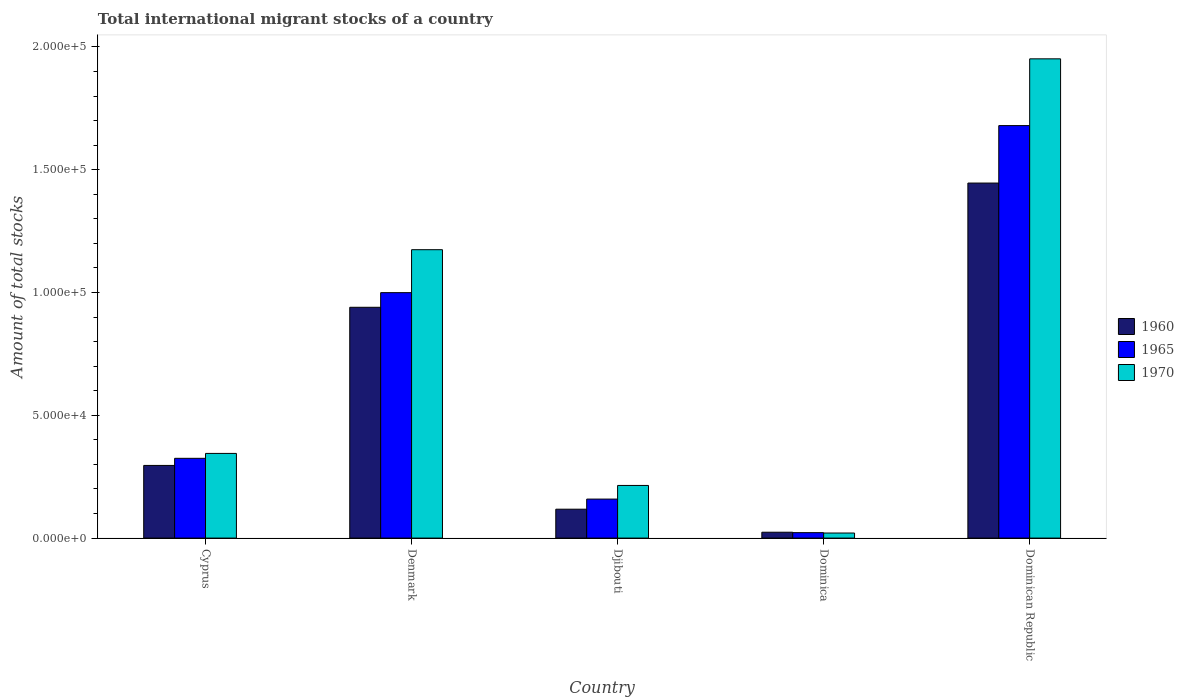How many groups of bars are there?
Offer a very short reply. 5. Are the number of bars per tick equal to the number of legend labels?
Your response must be concise. Yes. Are the number of bars on each tick of the X-axis equal?
Offer a terse response. Yes. How many bars are there on the 4th tick from the left?
Ensure brevity in your answer.  3. What is the label of the 4th group of bars from the left?
Offer a very short reply. Dominica. What is the amount of total stocks in in 1965 in Dominican Republic?
Give a very brief answer. 1.68e+05. Across all countries, what is the maximum amount of total stocks in in 1970?
Ensure brevity in your answer.  1.95e+05. Across all countries, what is the minimum amount of total stocks in in 1960?
Your answer should be compact. 2390. In which country was the amount of total stocks in in 1970 maximum?
Your answer should be very brief. Dominican Republic. In which country was the amount of total stocks in in 1970 minimum?
Provide a succinct answer. Dominica. What is the total amount of total stocks in in 1965 in the graph?
Keep it short and to the point. 3.19e+05. What is the difference between the amount of total stocks in in 1970 in Djibouti and that in Dominican Republic?
Provide a short and direct response. -1.74e+05. What is the difference between the amount of total stocks in in 1970 in Dominican Republic and the amount of total stocks in in 1965 in Cyprus?
Provide a short and direct response. 1.63e+05. What is the average amount of total stocks in in 1965 per country?
Your answer should be very brief. 6.37e+04. What is the difference between the amount of total stocks in of/in 1965 and amount of total stocks in of/in 1960 in Djibouti?
Give a very brief answer. 4117. What is the ratio of the amount of total stocks in in 1970 in Cyprus to that in Denmark?
Offer a terse response. 0.29. What is the difference between the highest and the second highest amount of total stocks in in 1960?
Offer a terse response. 6.44e+04. What is the difference between the highest and the lowest amount of total stocks in in 1970?
Your answer should be very brief. 1.93e+05. In how many countries, is the amount of total stocks in in 1965 greater than the average amount of total stocks in in 1965 taken over all countries?
Ensure brevity in your answer.  2. Is the sum of the amount of total stocks in in 1970 in Denmark and Dominican Republic greater than the maximum amount of total stocks in in 1965 across all countries?
Ensure brevity in your answer.  Yes. What does the 2nd bar from the left in Cyprus represents?
Offer a terse response. 1965. What does the 1st bar from the right in Dominica represents?
Provide a short and direct response. 1970. Is it the case that in every country, the sum of the amount of total stocks in in 1970 and amount of total stocks in in 1960 is greater than the amount of total stocks in in 1965?
Make the answer very short. Yes. Are all the bars in the graph horizontal?
Keep it short and to the point. No. Are the values on the major ticks of Y-axis written in scientific E-notation?
Offer a very short reply. Yes. Does the graph contain any zero values?
Keep it short and to the point. No. How many legend labels are there?
Offer a terse response. 3. What is the title of the graph?
Offer a terse response. Total international migrant stocks of a country. Does "2006" appear as one of the legend labels in the graph?
Your answer should be compact. No. What is the label or title of the Y-axis?
Offer a terse response. Amount of total stocks. What is the Amount of total stocks of 1960 in Cyprus?
Your answer should be compact. 2.96e+04. What is the Amount of total stocks of 1965 in Cyprus?
Provide a succinct answer. 3.25e+04. What is the Amount of total stocks of 1970 in Cyprus?
Provide a succinct answer. 3.45e+04. What is the Amount of total stocks of 1960 in Denmark?
Keep it short and to the point. 9.40e+04. What is the Amount of total stocks of 1965 in Denmark?
Give a very brief answer. 1.00e+05. What is the Amount of total stocks in 1970 in Denmark?
Provide a short and direct response. 1.17e+05. What is the Amount of total stocks in 1960 in Djibouti?
Provide a short and direct response. 1.18e+04. What is the Amount of total stocks in 1965 in Djibouti?
Make the answer very short. 1.59e+04. What is the Amount of total stocks of 1970 in Djibouti?
Ensure brevity in your answer.  2.14e+04. What is the Amount of total stocks of 1960 in Dominica?
Keep it short and to the point. 2390. What is the Amount of total stocks of 1965 in Dominica?
Your answer should be very brief. 2219. What is the Amount of total stocks in 1970 in Dominica?
Provide a succinct answer. 2061. What is the Amount of total stocks of 1960 in Dominican Republic?
Your answer should be very brief. 1.45e+05. What is the Amount of total stocks in 1965 in Dominican Republic?
Offer a terse response. 1.68e+05. What is the Amount of total stocks of 1970 in Dominican Republic?
Provide a short and direct response. 1.95e+05. Across all countries, what is the maximum Amount of total stocks in 1960?
Give a very brief answer. 1.45e+05. Across all countries, what is the maximum Amount of total stocks in 1965?
Ensure brevity in your answer.  1.68e+05. Across all countries, what is the maximum Amount of total stocks in 1970?
Provide a short and direct response. 1.95e+05. Across all countries, what is the minimum Amount of total stocks in 1960?
Your answer should be compact. 2390. Across all countries, what is the minimum Amount of total stocks of 1965?
Offer a very short reply. 2219. Across all countries, what is the minimum Amount of total stocks of 1970?
Make the answer very short. 2061. What is the total Amount of total stocks in 1960 in the graph?
Provide a short and direct response. 2.82e+05. What is the total Amount of total stocks in 1965 in the graph?
Offer a very short reply. 3.19e+05. What is the total Amount of total stocks in 1970 in the graph?
Your response must be concise. 3.71e+05. What is the difference between the Amount of total stocks of 1960 in Cyprus and that in Denmark?
Provide a succinct answer. -6.44e+04. What is the difference between the Amount of total stocks in 1965 in Cyprus and that in Denmark?
Your answer should be compact. -6.75e+04. What is the difference between the Amount of total stocks of 1970 in Cyprus and that in Denmark?
Your answer should be very brief. -8.30e+04. What is the difference between the Amount of total stocks in 1960 in Cyprus and that in Djibouti?
Your answer should be very brief. 1.78e+04. What is the difference between the Amount of total stocks of 1965 in Cyprus and that in Djibouti?
Give a very brief answer. 1.66e+04. What is the difference between the Amount of total stocks of 1970 in Cyprus and that in Djibouti?
Provide a succinct answer. 1.30e+04. What is the difference between the Amount of total stocks of 1960 in Cyprus and that in Dominica?
Your response must be concise. 2.72e+04. What is the difference between the Amount of total stocks of 1965 in Cyprus and that in Dominica?
Offer a terse response. 3.03e+04. What is the difference between the Amount of total stocks of 1970 in Cyprus and that in Dominica?
Your answer should be compact. 3.24e+04. What is the difference between the Amount of total stocks in 1960 in Cyprus and that in Dominican Republic?
Provide a succinct answer. -1.15e+05. What is the difference between the Amount of total stocks of 1965 in Cyprus and that in Dominican Republic?
Provide a short and direct response. -1.35e+05. What is the difference between the Amount of total stocks of 1970 in Cyprus and that in Dominican Republic?
Make the answer very short. -1.61e+05. What is the difference between the Amount of total stocks in 1960 in Denmark and that in Djibouti?
Provide a short and direct response. 8.22e+04. What is the difference between the Amount of total stocks in 1965 in Denmark and that in Djibouti?
Your answer should be compact. 8.41e+04. What is the difference between the Amount of total stocks in 1970 in Denmark and that in Djibouti?
Offer a very short reply. 9.60e+04. What is the difference between the Amount of total stocks in 1960 in Denmark and that in Dominica?
Ensure brevity in your answer.  9.16e+04. What is the difference between the Amount of total stocks in 1965 in Denmark and that in Dominica?
Offer a terse response. 9.77e+04. What is the difference between the Amount of total stocks of 1970 in Denmark and that in Dominica?
Your response must be concise. 1.15e+05. What is the difference between the Amount of total stocks of 1960 in Denmark and that in Dominican Republic?
Your answer should be compact. -5.06e+04. What is the difference between the Amount of total stocks of 1965 in Denmark and that in Dominican Republic?
Provide a short and direct response. -6.80e+04. What is the difference between the Amount of total stocks of 1970 in Denmark and that in Dominican Republic?
Your answer should be very brief. -7.77e+04. What is the difference between the Amount of total stocks of 1960 in Djibouti and that in Dominica?
Make the answer very short. 9376. What is the difference between the Amount of total stocks in 1965 in Djibouti and that in Dominica?
Give a very brief answer. 1.37e+04. What is the difference between the Amount of total stocks of 1970 in Djibouti and that in Dominica?
Offer a very short reply. 1.94e+04. What is the difference between the Amount of total stocks in 1960 in Djibouti and that in Dominican Republic?
Offer a very short reply. -1.33e+05. What is the difference between the Amount of total stocks of 1965 in Djibouti and that in Dominican Republic?
Keep it short and to the point. -1.52e+05. What is the difference between the Amount of total stocks of 1970 in Djibouti and that in Dominican Republic?
Keep it short and to the point. -1.74e+05. What is the difference between the Amount of total stocks in 1960 in Dominica and that in Dominican Republic?
Give a very brief answer. -1.42e+05. What is the difference between the Amount of total stocks in 1965 in Dominica and that in Dominican Republic?
Your answer should be very brief. -1.66e+05. What is the difference between the Amount of total stocks of 1970 in Dominica and that in Dominican Republic?
Offer a very short reply. -1.93e+05. What is the difference between the Amount of total stocks of 1960 in Cyprus and the Amount of total stocks of 1965 in Denmark?
Keep it short and to the point. -7.04e+04. What is the difference between the Amount of total stocks in 1960 in Cyprus and the Amount of total stocks in 1970 in Denmark?
Give a very brief answer. -8.79e+04. What is the difference between the Amount of total stocks of 1965 in Cyprus and the Amount of total stocks of 1970 in Denmark?
Your answer should be compact. -8.50e+04. What is the difference between the Amount of total stocks in 1960 in Cyprus and the Amount of total stocks in 1965 in Djibouti?
Provide a succinct answer. 1.37e+04. What is the difference between the Amount of total stocks of 1960 in Cyprus and the Amount of total stocks of 1970 in Djibouti?
Your answer should be compact. 8149. What is the difference between the Amount of total stocks in 1965 in Cyprus and the Amount of total stocks in 1970 in Djibouti?
Ensure brevity in your answer.  1.10e+04. What is the difference between the Amount of total stocks in 1960 in Cyprus and the Amount of total stocks in 1965 in Dominica?
Offer a very short reply. 2.74e+04. What is the difference between the Amount of total stocks in 1960 in Cyprus and the Amount of total stocks in 1970 in Dominica?
Ensure brevity in your answer.  2.75e+04. What is the difference between the Amount of total stocks in 1965 in Cyprus and the Amount of total stocks in 1970 in Dominica?
Provide a short and direct response. 3.04e+04. What is the difference between the Amount of total stocks in 1960 in Cyprus and the Amount of total stocks in 1965 in Dominican Republic?
Offer a very short reply. -1.38e+05. What is the difference between the Amount of total stocks of 1960 in Cyprus and the Amount of total stocks of 1970 in Dominican Republic?
Make the answer very short. -1.66e+05. What is the difference between the Amount of total stocks of 1965 in Cyprus and the Amount of total stocks of 1970 in Dominican Republic?
Offer a terse response. -1.63e+05. What is the difference between the Amount of total stocks of 1960 in Denmark and the Amount of total stocks of 1965 in Djibouti?
Offer a very short reply. 7.81e+04. What is the difference between the Amount of total stocks of 1960 in Denmark and the Amount of total stocks of 1970 in Djibouti?
Offer a terse response. 7.25e+04. What is the difference between the Amount of total stocks of 1965 in Denmark and the Amount of total stocks of 1970 in Djibouti?
Your answer should be very brief. 7.85e+04. What is the difference between the Amount of total stocks of 1960 in Denmark and the Amount of total stocks of 1965 in Dominica?
Keep it short and to the point. 9.18e+04. What is the difference between the Amount of total stocks in 1960 in Denmark and the Amount of total stocks in 1970 in Dominica?
Ensure brevity in your answer.  9.19e+04. What is the difference between the Amount of total stocks in 1965 in Denmark and the Amount of total stocks in 1970 in Dominica?
Your answer should be compact. 9.79e+04. What is the difference between the Amount of total stocks of 1960 in Denmark and the Amount of total stocks of 1965 in Dominican Republic?
Your answer should be very brief. -7.40e+04. What is the difference between the Amount of total stocks in 1960 in Denmark and the Amount of total stocks in 1970 in Dominican Republic?
Your answer should be compact. -1.01e+05. What is the difference between the Amount of total stocks of 1965 in Denmark and the Amount of total stocks of 1970 in Dominican Republic?
Your answer should be very brief. -9.52e+04. What is the difference between the Amount of total stocks of 1960 in Djibouti and the Amount of total stocks of 1965 in Dominica?
Your answer should be very brief. 9547. What is the difference between the Amount of total stocks of 1960 in Djibouti and the Amount of total stocks of 1970 in Dominica?
Provide a succinct answer. 9705. What is the difference between the Amount of total stocks of 1965 in Djibouti and the Amount of total stocks of 1970 in Dominica?
Provide a succinct answer. 1.38e+04. What is the difference between the Amount of total stocks of 1960 in Djibouti and the Amount of total stocks of 1965 in Dominican Republic?
Ensure brevity in your answer.  -1.56e+05. What is the difference between the Amount of total stocks in 1960 in Djibouti and the Amount of total stocks in 1970 in Dominican Republic?
Offer a terse response. -1.83e+05. What is the difference between the Amount of total stocks of 1965 in Djibouti and the Amount of total stocks of 1970 in Dominican Republic?
Offer a very short reply. -1.79e+05. What is the difference between the Amount of total stocks in 1960 in Dominica and the Amount of total stocks in 1965 in Dominican Republic?
Your answer should be compact. -1.66e+05. What is the difference between the Amount of total stocks of 1960 in Dominica and the Amount of total stocks of 1970 in Dominican Republic?
Provide a short and direct response. -1.93e+05. What is the difference between the Amount of total stocks of 1965 in Dominica and the Amount of total stocks of 1970 in Dominican Republic?
Ensure brevity in your answer.  -1.93e+05. What is the average Amount of total stocks of 1960 per country?
Your response must be concise. 5.65e+04. What is the average Amount of total stocks in 1965 per country?
Your response must be concise. 6.37e+04. What is the average Amount of total stocks in 1970 per country?
Provide a succinct answer. 7.41e+04. What is the difference between the Amount of total stocks of 1960 and Amount of total stocks of 1965 in Cyprus?
Ensure brevity in your answer.  -2894. What is the difference between the Amount of total stocks in 1960 and Amount of total stocks in 1970 in Cyprus?
Provide a succinct answer. -4896. What is the difference between the Amount of total stocks of 1965 and Amount of total stocks of 1970 in Cyprus?
Give a very brief answer. -2002. What is the difference between the Amount of total stocks in 1960 and Amount of total stocks in 1965 in Denmark?
Your answer should be very brief. -5965. What is the difference between the Amount of total stocks of 1960 and Amount of total stocks of 1970 in Denmark?
Provide a short and direct response. -2.35e+04. What is the difference between the Amount of total stocks in 1965 and Amount of total stocks in 1970 in Denmark?
Offer a very short reply. -1.75e+04. What is the difference between the Amount of total stocks in 1960 and Amount of total stocks in 1965 in Djibouti?
Offer a terse response. -4117. What is the difference between the Amount of total stocks of 1960 and Amount of total stocks of 1970 in Djibouti?
Your response must be concise. -9674. What is the difference between the Amount of total stocks in 1965 and Amount of total stocks in 1970 in Djibouti?
Your answer should be compact. -5557. What is the difference between the Amount of total stocks in 1960 and Amount of total stocks in 1965 in Dominica?
Offer a very short reply. 171. What is the difference between the Amount of total stocks in 1960 and Amount of total stocks in 1970 in Dominica?
Your response must be concise. 329. What is the difference between the Amount of total stocks in 1965 and Amount of total stocks in 1970 in Dominica?
Give a very brief answer. 158. What is the difference between the Amount of total stocks in 1960 and Amount of total stocks in 1965 in Dominican Republic?
Your answer should be very brief. -2.34e+04. What is the difference between the Amount of total stocks of 1960 and Amount of total stocks of 1970 in Dominican Republic?
Ensure brevity in your answer.  -5.06e+04. What is the difference between the Amount of total stocks of 1965 and Amount of total stocks of 1970 in Dominican Republic?
Your answer should be very brief. -2.72e+04. What is the ratio of the Amount of total stocks in 1960 in Cyprus to that in Denmark?
Make the answer very short. 0.31. What is the ratio of the Amount of total stocks of 1965 in Cyprus to that in Denmark?
Provide a short and direct response. 0.33. What is the ratio of the Amount of total stocks in 1970 in Cyprus to that in Denmark?
Provide a succinct answer. 0.29. What is the ratio of the Amount of total stocks in 1960 in Cyprus to that in Djibouti?
Your response must be concise. 2.51. What is the ratio of the Amount of total stocks in 1965 in Cyprus to that in Djibouti?
Ensure brevity in your answer.  2.05. What is the ratio of the Amount of total stocks in 1970 in Cyprus to that in Djibouti?
Your answer should be very brief. 1.61. What is the ratio of the Amount of total stocks in 1960 in Cyprus to that in Dominica?
Your response must be concise. 12.38. What is the ratio of the Amount of total stocks of 1965 in Cyprus to that in Dominica?
Make the answer very short. 14.64. What is the ratio of the Amount of total stocks in 1970 in Cyprus to that in Dominica?
Your response must be concise. 16.73. What is the ratio of the Amount of total stocks in 1960 in Cyprus to that in Dominican Republic?
Your answer should be compact. 0.2. What is the ratio of the Amount of total stocks of 1965 in Cyprus to that in Dominican Republic?
Provide a short and direct response. 0.19. What is the ratio of the Amount of total stocks of 1970 in Cyprus to that in Dominican Republic?
Provide a succinct answer. 0.18. What is the ratio of the Amount of total stocks in 1960 in Denmark to that in Djibouti?
Keep it short and to the point. 7.99. What is the ratio of the Amount of total stocks in 1965 in Denmark to that in Djibouti?
Your response must be concise. 6.29. What is the ratio of the Amount of total stocks in 1970 in Denmark to that in Djibouti?
Your answer should be compact. 5.48. What is the ratio of the Amount of total stocks in 1960 in Denmark to that in Dominica?
Offer a very short reply. 39.33. What is the ratio of the Amount of total stocks in 1965 in Denmark to that in Dominica?
Your answer should be very brief. 45.04. What is the ratio of the Amount of total stocks of 1970 in Denmark to that in Dominica?
Provide a short and direct response. 56.98. What is the ratio of the Amount of total stocks in 1960 in Denmark to that in Dominican Republic?
Offer a terse response. 0.65. What is the ratio of the Amount of total stocks of 1965 in Denmark to that in Dominican Republic?
Provide a short and direct response. 0.59. What is the ratio of the Amount of total stocks in 1970 in Denmark to that in Dominican Republic?
Your answer should be compact. 0.6. What is the ratio of the Amount of total stocks of 1960 in Djibouti to that in Dominica?
Make the answer very short. 4.92. What is the ratio of the Amount of total stocks of 1965 in Djibouti to that in Dominica?
Offer a very short reply. 7.16. What is the ratio of the Amount of total stocks in 1970 in Djibouti to that in Dominica?
Keep it short and to the point. 10.4. What is the ratio of the Amount of total stocks of 1960 in Djibouti to that in Dominican Republic?
Give a very brief answer. 0.08. What is the ratio of the Amount of total stocks in 1965 in Djibouti to that in Dominican Republic?
Keep it short and to the point. 0.09. What is the ratio of the Amount of total stocks of 1970 in Djibouti to that in Dominican Republic?
Keep it short and to the point. 0.11. What is the ratio of the Amount of total stocks of 1960 in Dominica to that in Dominican Republic?
Your answer should be compact. 0.02. What is the ratio of the Amount of total stocks in 1965 in Dominica to that in Dominican Republic?
Offer a terse response. 0.01. What is the ratio of the Amount of total stocks of 1970 in Dominica to that in Dominican Republic?
Your response must be concise. 0.01. What is the difference between the highest and the second highest Amount of total stocks of 1960?
Your response must be concise. 5.06e+04. What is the difference between the highest and the second highest Amount of total stocks of 1965?
Your answer should be very brief. 6.80e+04. What is the difference between the highest and the second highest Amount of total stocks in 1970?
Your answer should be compact. 7.77e+04. What is the difference between the highest and the lowest Amount of total stocks in 1960?
Provide a short and direct response. 1.42e+05. What is the difference between the highest and the lowest Amount of total stocks of 1965?
Offer a very short reply. 1.66e+05. What is the difference between the highest and the lowest Amount of total stocks of 1970?
Your answer should be compact. 1.93e+05. 